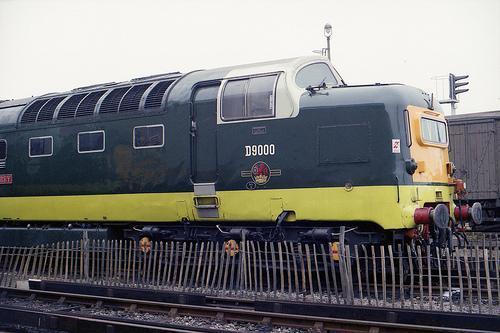How many trains are there?
Give a very brief answer. 1. 